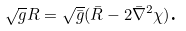<formula> <loc_0><loc_0><loc_500><loc_500>\sqrt { g } R = \sqrt { \bar { g } } ( \bar { R } - 2 \bar { \nabla } ^ { 2 } \chi ) \text {.}</formula> 